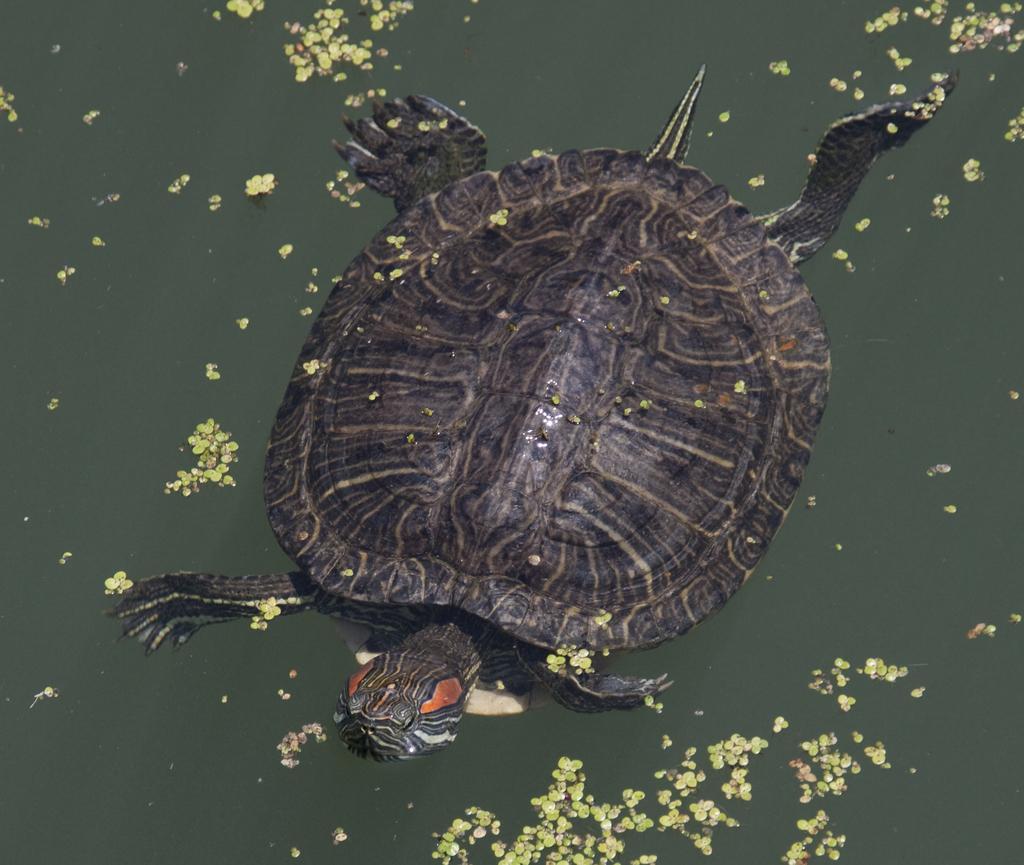Please provide a concise description of this image. In the image we can see water, above the water a tortoise is swimming. 